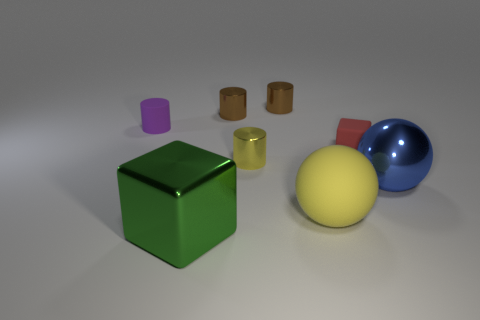There is a yellow object that is behind the blue ball; is its shape the same as the green thing?
Give a very brief answer. No. What number of tiny objects are both on the left side of the small yellow thing and in front of the small red matte thing?
Make the answer very short. 0. How many other things are there of the same size as the blue ball?
Provide a succinct answer. 2. Is the number of red rubber cubes in front of the matte sphere the same as the number of tiny red blocks?
Your response must be concise. No. There is a small cylinder in front of the purple rubber cylinder; does it have the same color as the small rubber object in front of the rubber cylinder?
Your answer should be very brief. No. What material is the object that is both in front of the yellow shiny thing and behind the big rubber object?
Provide a succinct answer. Metal. The small matte cube has what color?
Provide a short and direct response. Red. How many other objects are there of the same shape as the tiny purple matte thing?
Your answer should be compact. 3. Are there the same number of large green metal cubes behind the small matte block and large metal blocks that are right of the small yellow object?
Provide a short and direct response. Yes. What material is the big yellow thing?
Offer a very short reply. Rubber. 